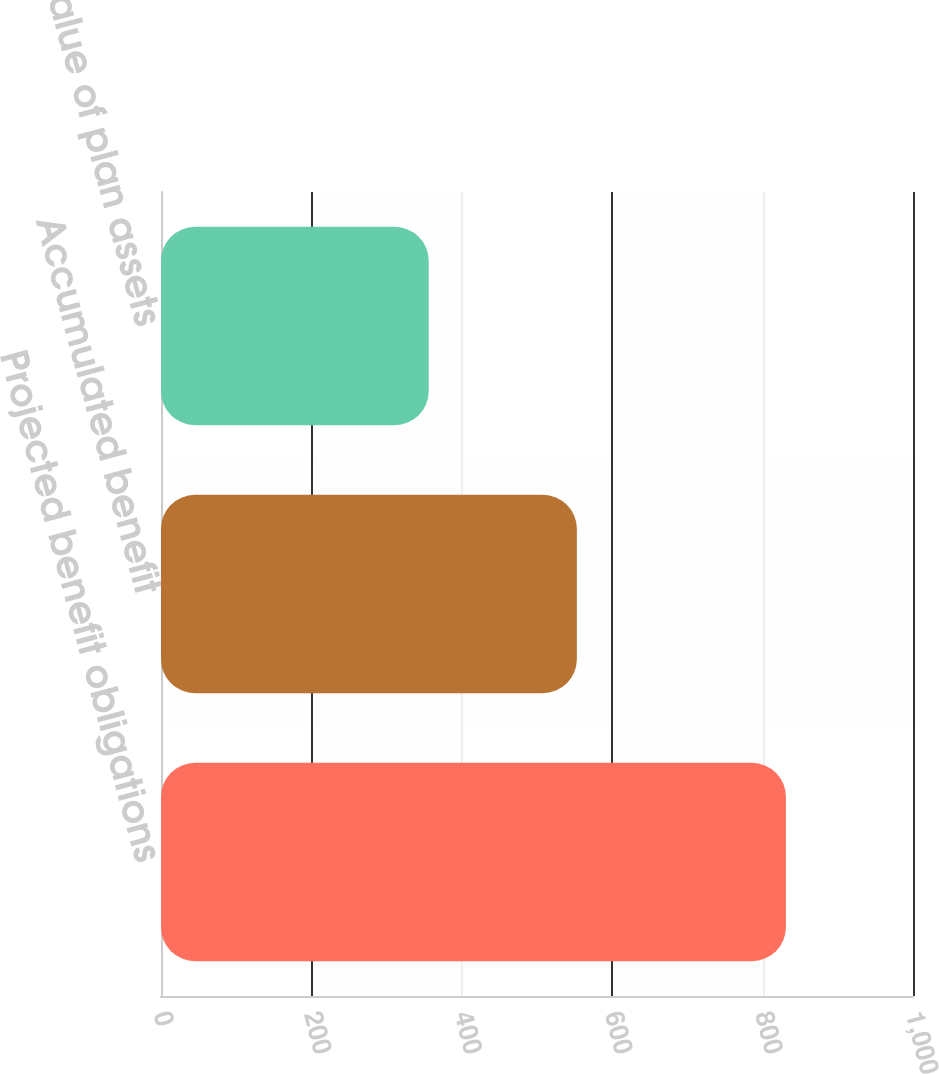Convert chart to OTSL. <chart><loc_0><loc_0><loc_500><loc_500><bar_chart><fcel>Projected benefit obligations<fcel>Accumulated benefit<fcel>Fair value of plan assets<nl><fcel>831<fcel>553<fcel>356<nl></chart> 